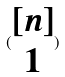<formula> <loc_0><loc_0><loc_500><loc_500>( \begin{matrix} [ n ] \\ 1 \end{matrix} )</formula> 